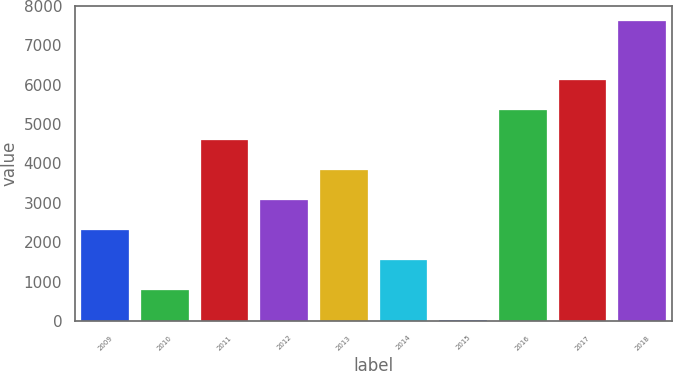Convert chart to OTSL. <chart><loc_0><loc_0><loc_500><loc_500><bar_chart><fcel>2009<fcel>2010<fcel>2011<fcel>2012<fcel>2013<fcel>2014<fcel>2015<fcel>2016<fcel>2017<fcel>2018<nl><fcel>2306.9<fcel>788.3<fcel>4584.8<fcel>3066.2<fcel>3825.5<fcel>1547.6<fcel>29<fcel>5344.1<fcel>6103.4<fcel>7622<nl></chart> 